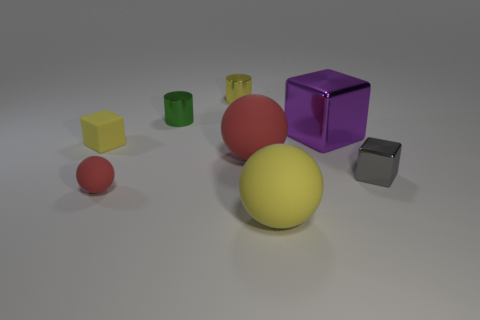Add 1 small shiny things. How many objects exist? 9 Subtract all cylinders. How many objects are left? 6 Add 6 big yellow things. How many big yellow things are left? 7 Add 4 gray metallic things. How many gray metallic things exist? 5 Subtract 0 brown blocks. How many objects are left? 8 Subtract all blue shiny cylinders. Subtract all spheres. How many objects are left? 5 